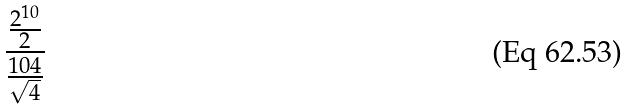<formula> <loc_0><loc_0><loc_500><loc_500>\frac { \frac { 2 ^ { 1 0 } } { 2 } } { \frac { 1 0 4 } { \sqrt { 4 } } }</formula> 